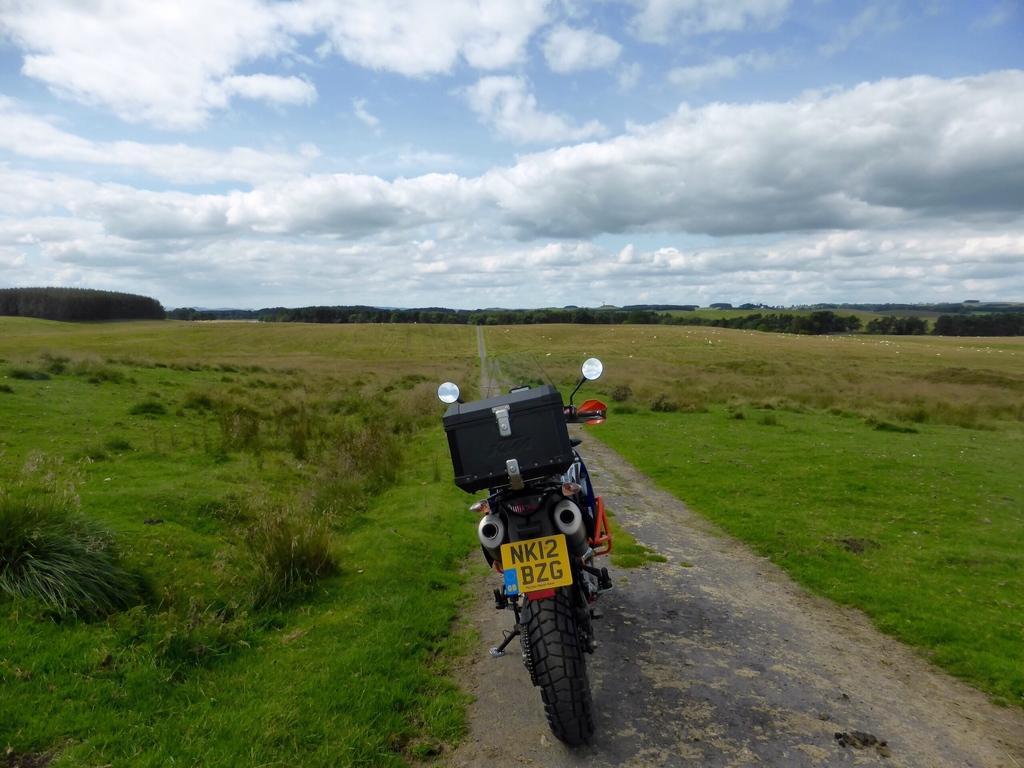Can you describe this image briefly? In this image there is a bike parked on the road. On the either sides of the road there is the ground. There are plants and grass on the ground. In the background there are trees. At the top there is the sky. 